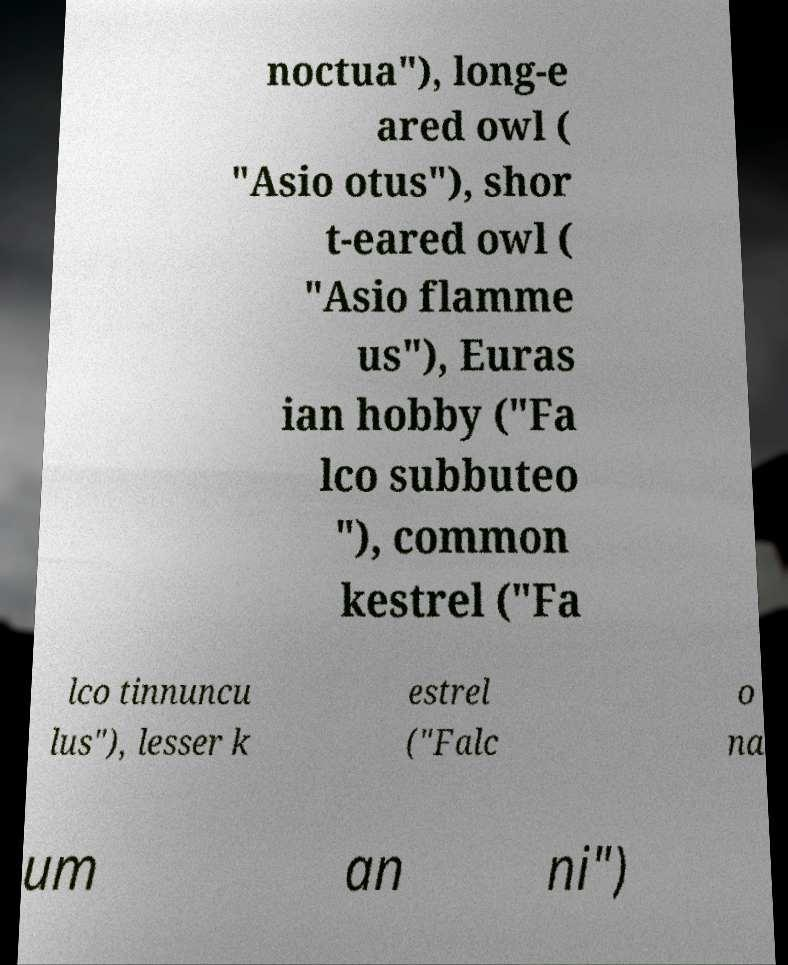Please identify and transcribe the text found in this image. noctua"), long-e ared owl ( "Asio otus"), shor t-eared owl ( "Asio flamme us"), Euras ian hobby ("Fa lco subbuteo "), common kestrel ("Fa lco tinnuncu lus"), lesser k estrel ("Falc o na um an ni") 